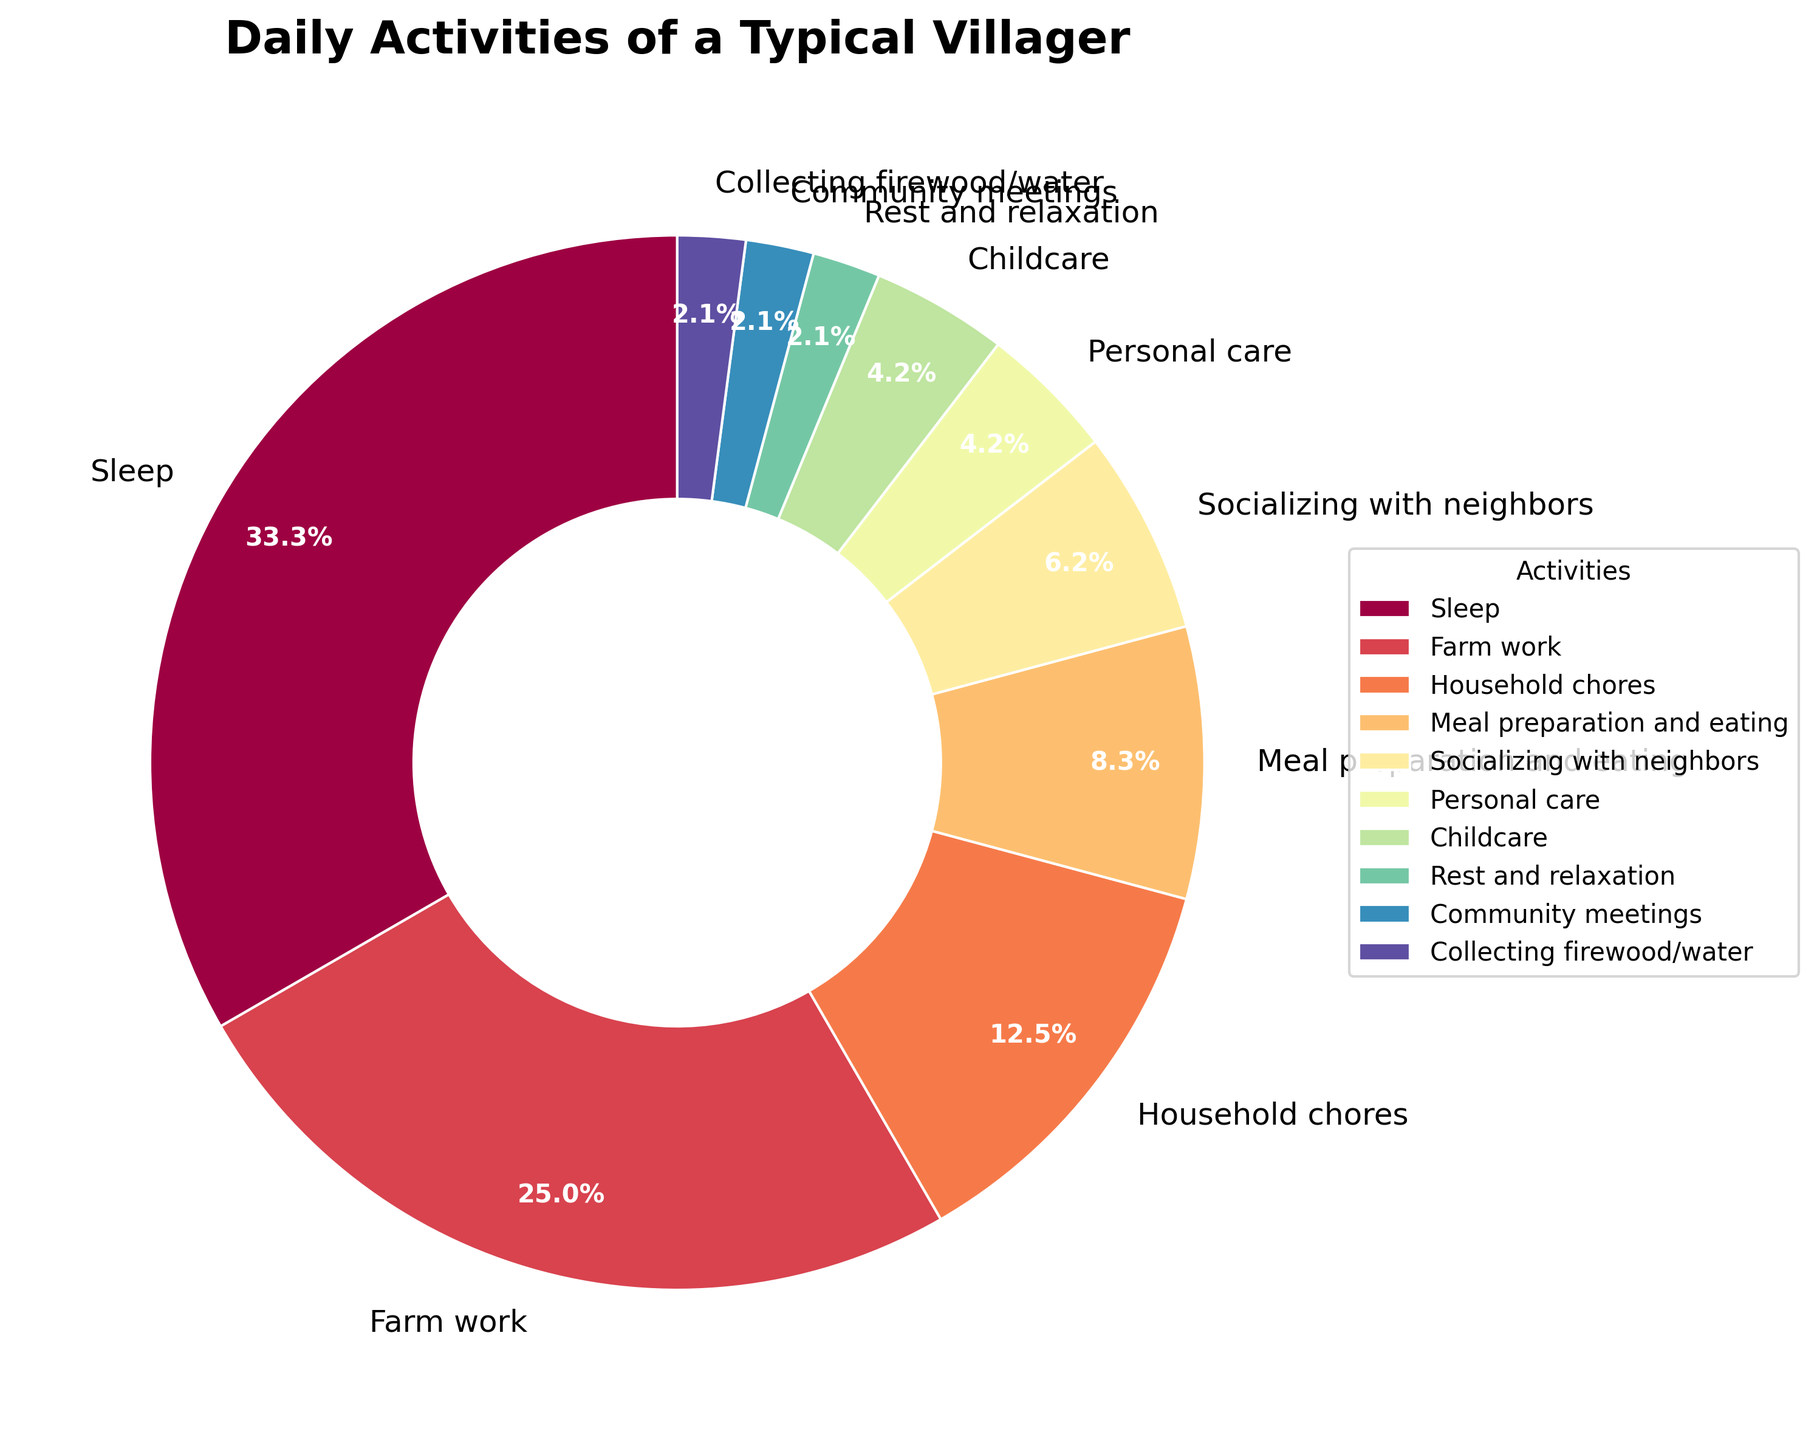What's the total percentage of time spent on Meal preparation and eating, Personal care, and Childcare combined? First, find the percentages for Meal preparation and eating (8.3%), Personal care (4.2%), and Childcare (4.2%). Add these percentages together: 8.3 + 4.2 + 4.2 = 16.7
Answer: 16.7% Which activity takes more time, Socializing with neighbors or Rest and relaxation? Socializing with neighbors accounts for 6.3% of the time, while Rest and relaxation takes up 2.1%. Thus, Socializing with neighbors takes more time.
Answer: Socializing with neighbors What is the difference in hours between the activity with the most time spent and the activity with the least time spent? Sleep has the most time spent (8 hours) and Rest and relaxation, Community meetings, and Collecting firewood/water each have the least time spent (0.5 hours). The difference is 8 - 0.5 = 7.5 hours.
Answer: 7.5 hours How much time is spent on activities other than Sleep? Total time spent per day is 24 hours. Subtract the time spent on Sleep (8 hours) from the total: 24 - 8 = 16 hours.
Answer: 16 hours Which activity has a larger percentage, Household chores or Farm work? Household chores take up 12.5% and Farm work takes up 25% of the time. Farm work has a larger percentage.
Answer: Farm work If the time spent on Community meetings is increased by 0.5 hours, what will be the new percentage of time spent on this activity? Initially, Community meetings take 0.5 hours (2.1%). Increasing by 0.5 hours makes it 1 hour. Total hours become 24.5. New percentage is (1/24.5) * 100 ≈ 4.1%.
Answer: 4.1% What's the average percentage of time spent on Collecting firewood/water, Childcare, and Rest and relaxation? The percentages are 2.1%, 4.2%, and 2.1% respectively. Average percentage is (2.1 + 4.2 + 2.1) / 3 = 2.8%
Answer: 2.8% What percentage of time is spent on Socializing with neighbors compared to time spent on Household chores? Socializing with neighbors takes 1.5 hours (6.3%), and Household chores take 3 hours (12.5%). The percentage compared is (1.5/3) * 100 = 50%.
Answer: 50% What's the combined total number of hours spent on Personal care and Community meetings? Personal care is 1 hour, and Community meetings are 0.5 hours. Combined total is 1 + 0.5 = 1.5 hours.
Answer: 1.5 hours Which activity has the smallest slice in the pie chart? The slices for Rest and relaxation, Community meetings, and Collecting firewood/water are all 0.5 hours (2.1%). Among them, they are equally small.
Answer: Rest and relaxation, Community meetings, and Collecting firewood/water 